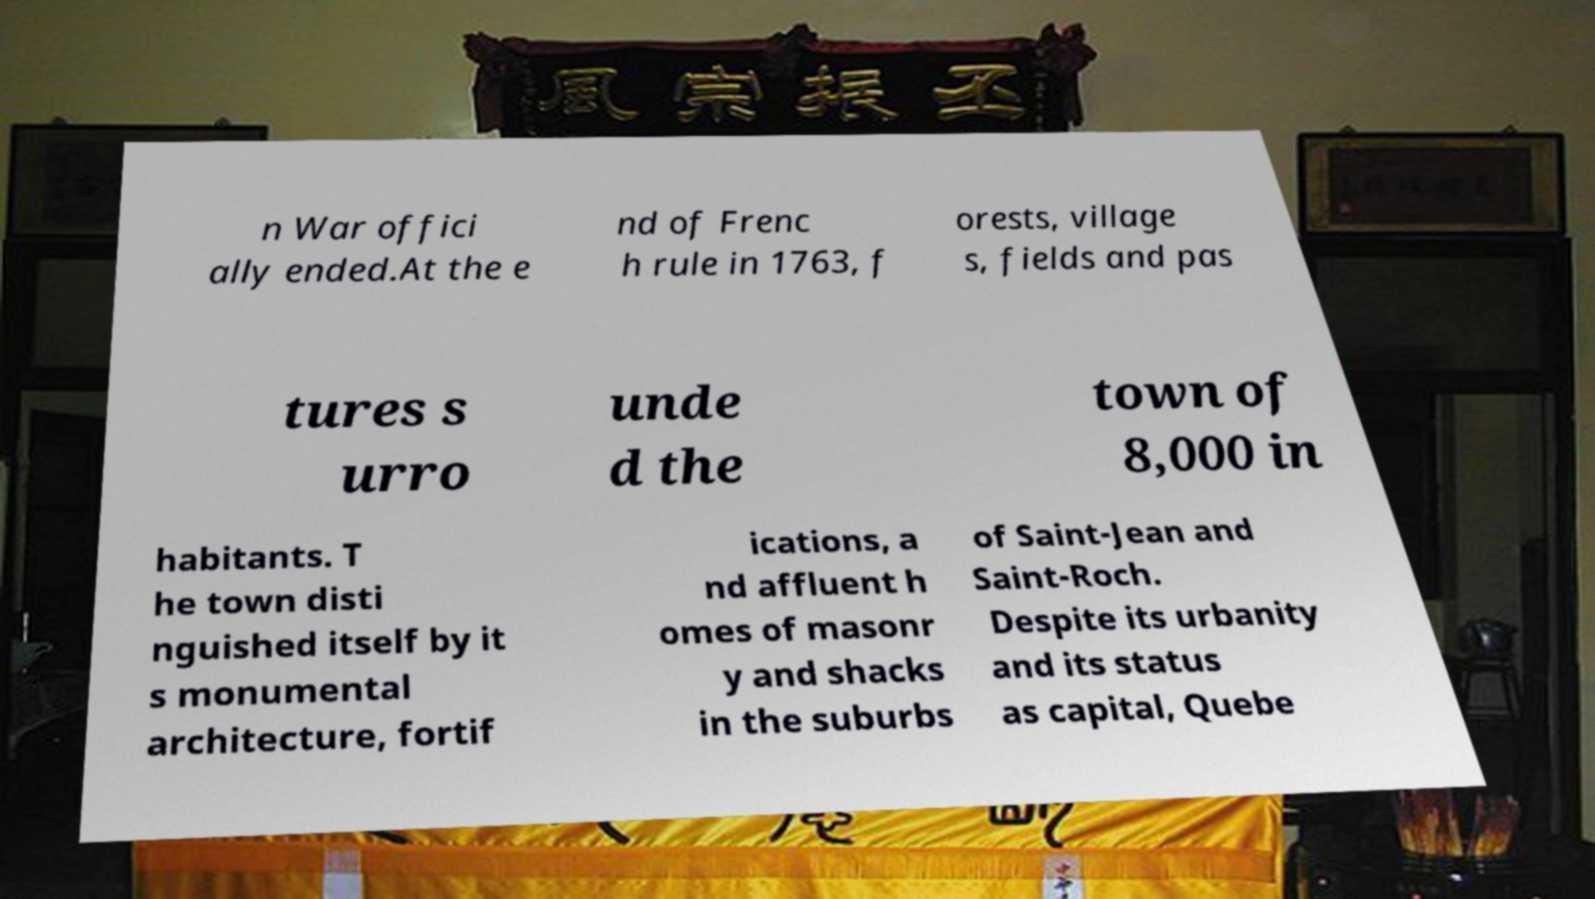There's text embedded in this image that I need extracted. Can you transcribe it verbatim? n War offici ally ended.At the e nd of Frenc h rule in 1763, f orests, village s, fields and pas tures s urro unde d the town of 8,000 in habitants. T he town disti nguished itself by it s monumental architecture, fortif ications, a nd affluent h omes of masonr y and shacks in the suburbs of Saint-Jean and Saint-Roch. Despite its urbanity and its status as capital, Quebe 